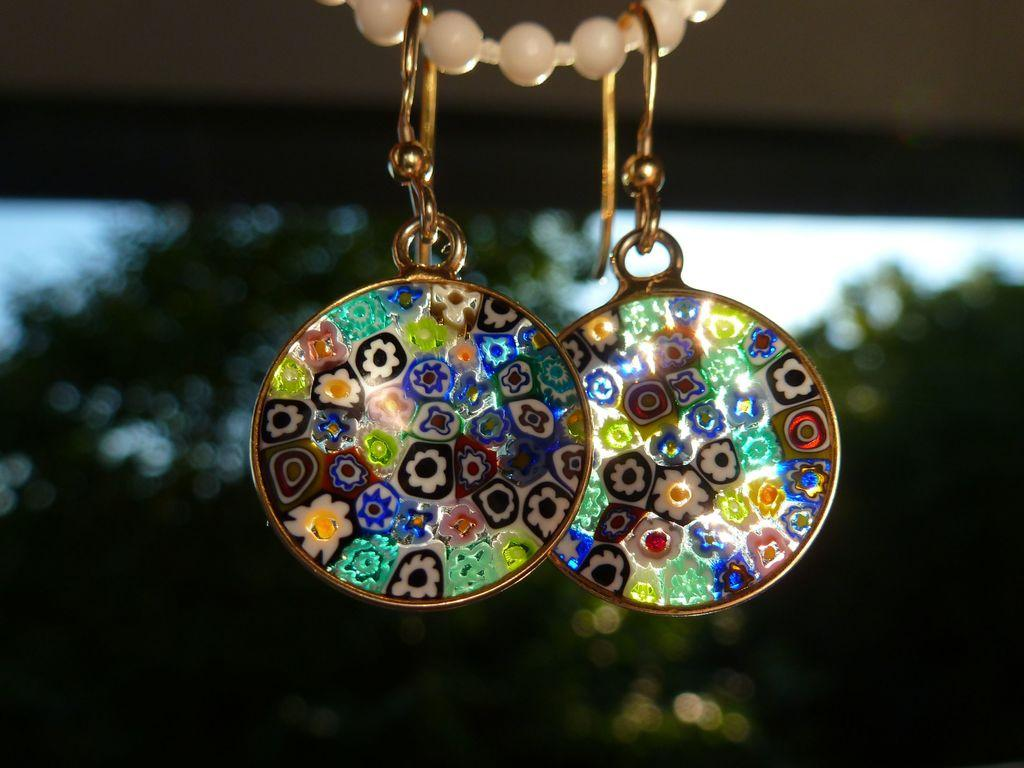What type of jewelry is featured in the image? There are two earrings in the image. How are the earrings displayed in the image? The earrings are hanging on a white beads chain. Can you describe the background of the image? The background of the image is blurred. How many stockings are hanging on the stove in the image? There are no stockings or stoves present in the image; it features two earrings hanging on a white beads chain. 